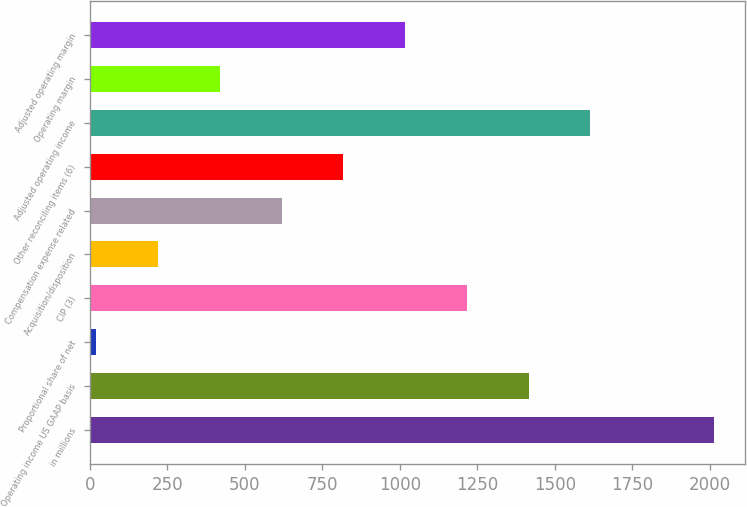<chart> <loc_0><loc_0><loc_500><loc_500><bar_chart><fcel>in millions<fcel>Operating income US GAAP basis<fcel>Proportional share of net<fcel>CIP (3)<fcel>Acquisition/disposition<fcel>Compensation expense related<fcel>Other reconciling items (6)<fcel>Adjusted operating income<fcel>Operating margin<fcel>Adjusted operating margin<nl><fcel>2013<fcel>1415.49<fcel>21.3<fcel>1216.32<fcel>220.47<fcel>618.81<fcel>817.98<fcel>1614.66<fcel>419.64<fcel>1017.15<nl></chart> 